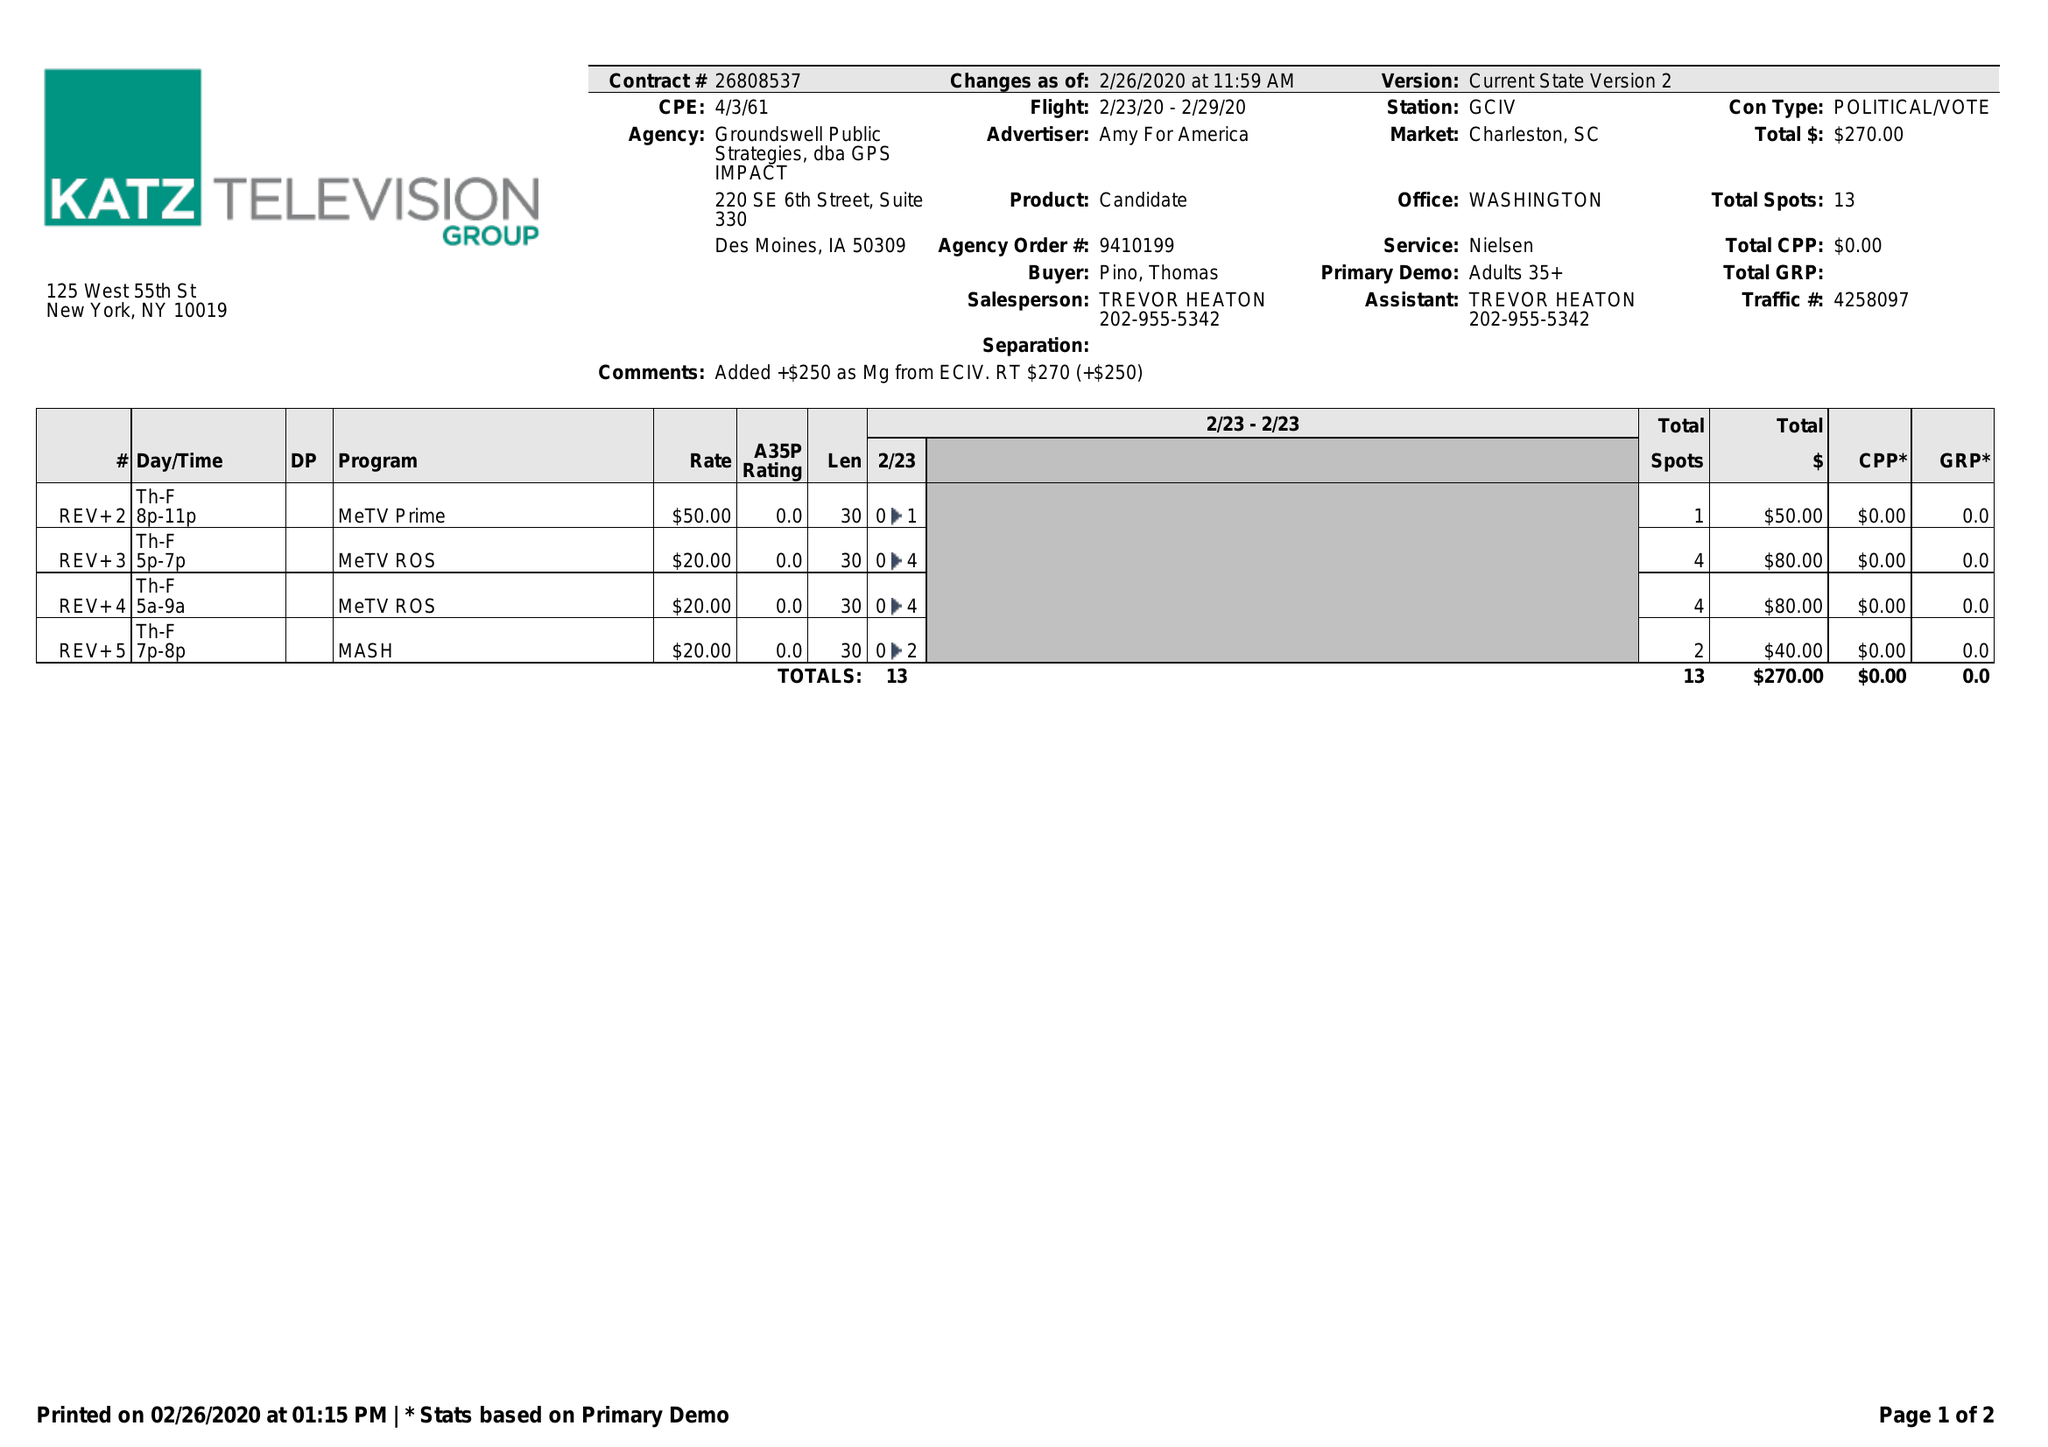What is the value for the contract_num?
Answer the question using a single word or phrase. 26808537 